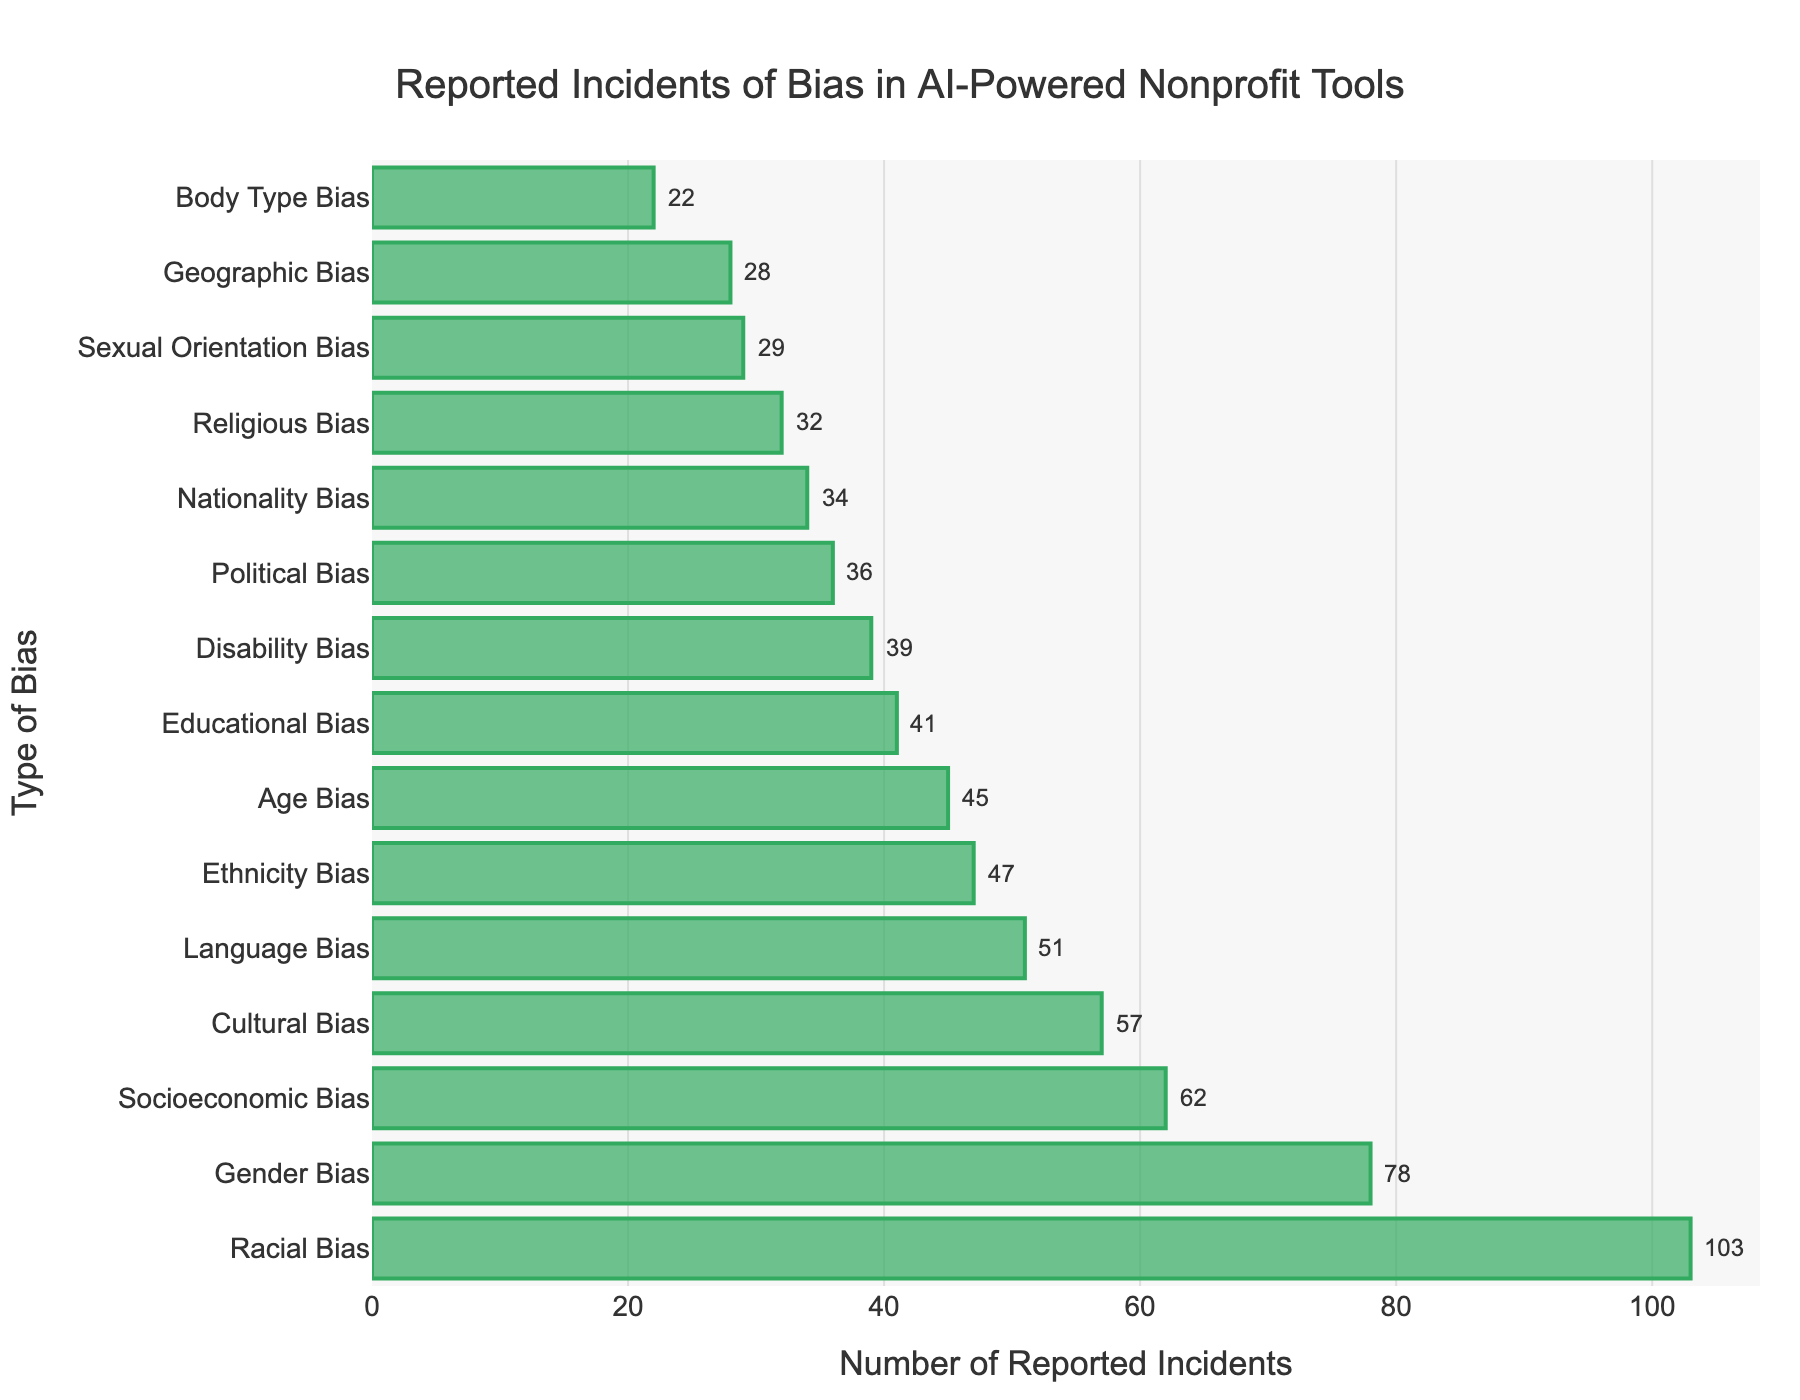Compare the number of reported incidents of Racial Bias and Geographic Bias. Which has more, and by how much? Racial Bias has 103 incidents, and Geographic Bias has 28. Subtract 28 from 103.
Answer: Racial Bias has 75 more incidents What's the total number of reported incidents for Gender Bias and Cultural Bias? Add the incidents for Gender Bias (78) and Cultural Bias (57) together.
Answer: 135 What is the median number of reported incidents across all bias types? The median is the middle value when the data is ordered. The sorted list: 22, 28, 29, 32, 34, 36, 39, 41, 45, 47, 51, 57, 62, 78, 103. The median is the middle value.
Answer: 41 How much greater is the number of reported incidents for Socioeconomic Bias compared to Political Bias? Socioeconomic Bias has 62 incidents, and Political Bias has 36 incidents. Subtract 36 from 62.
Answer: 26 more Rank the Bias Types in descending order of reported incidents. Use the visual length of the bars to order them from longest to shortest: Racial Bias, Gender Bias, Socioeconomic Bias, Cultural Bias, Ethnicity Bias, Age Bias, Language Bias, Educational Bias, Disability Bias, Political Bias, Sexual Orientation Bias, Religious Bias, Nationality Bias, Geographic Bias, Body Type Bias.
Answer: Racial Bias, Gender Bias, Socioeconomic Bias, Cultural Bias, Ethnicity Bias, Age Bias, Language Bias, Educational Bias, Disability Bias, Political Bias, Sexual Orientation Bias, Religious Bias, Nationality Bias, Geographic Bias, Body Type Bias What percentage of the total incidents does Language Bias represent? Sum all reported incidents (782). Language Bias has 51 incidents. Calculate (51 / 782) * 100 to find the percentage.
Answer: Approximately 6.52% How many reported incidents are there for biases related to personal identity (Gender, Racial, Age, Sexual Orientation, Body Type, Nationality, Ethnicity)? Add the incidents for each Bias Type: Gender (78), Racial (103), Age (45), Sexual Orientation (29), Body Type (22), Nationality (34), Ethnicity (47).
Answer: 358 Which Bias Types have fewer than 40 reported incidents? Look at the bars shorter than the 40 mark on the x-axis. These are Disability Bias (39), Religious Bias (32), Geographic Bias (28), Sexual Orientation Bias (29), Body Type Bias (22), Nationality Bias (34).
Answer: Disability Bias, Religious Bias, Geographic Bias, Sexual Orientation Bias, Body Type Bias, Nationality Bias What is the average number of reported incidents per Bias Type? Sum all reported incidents (782) and divide by the number of Bias Types (15). Calculate 782/15.
Answer: Approximately 52.13 